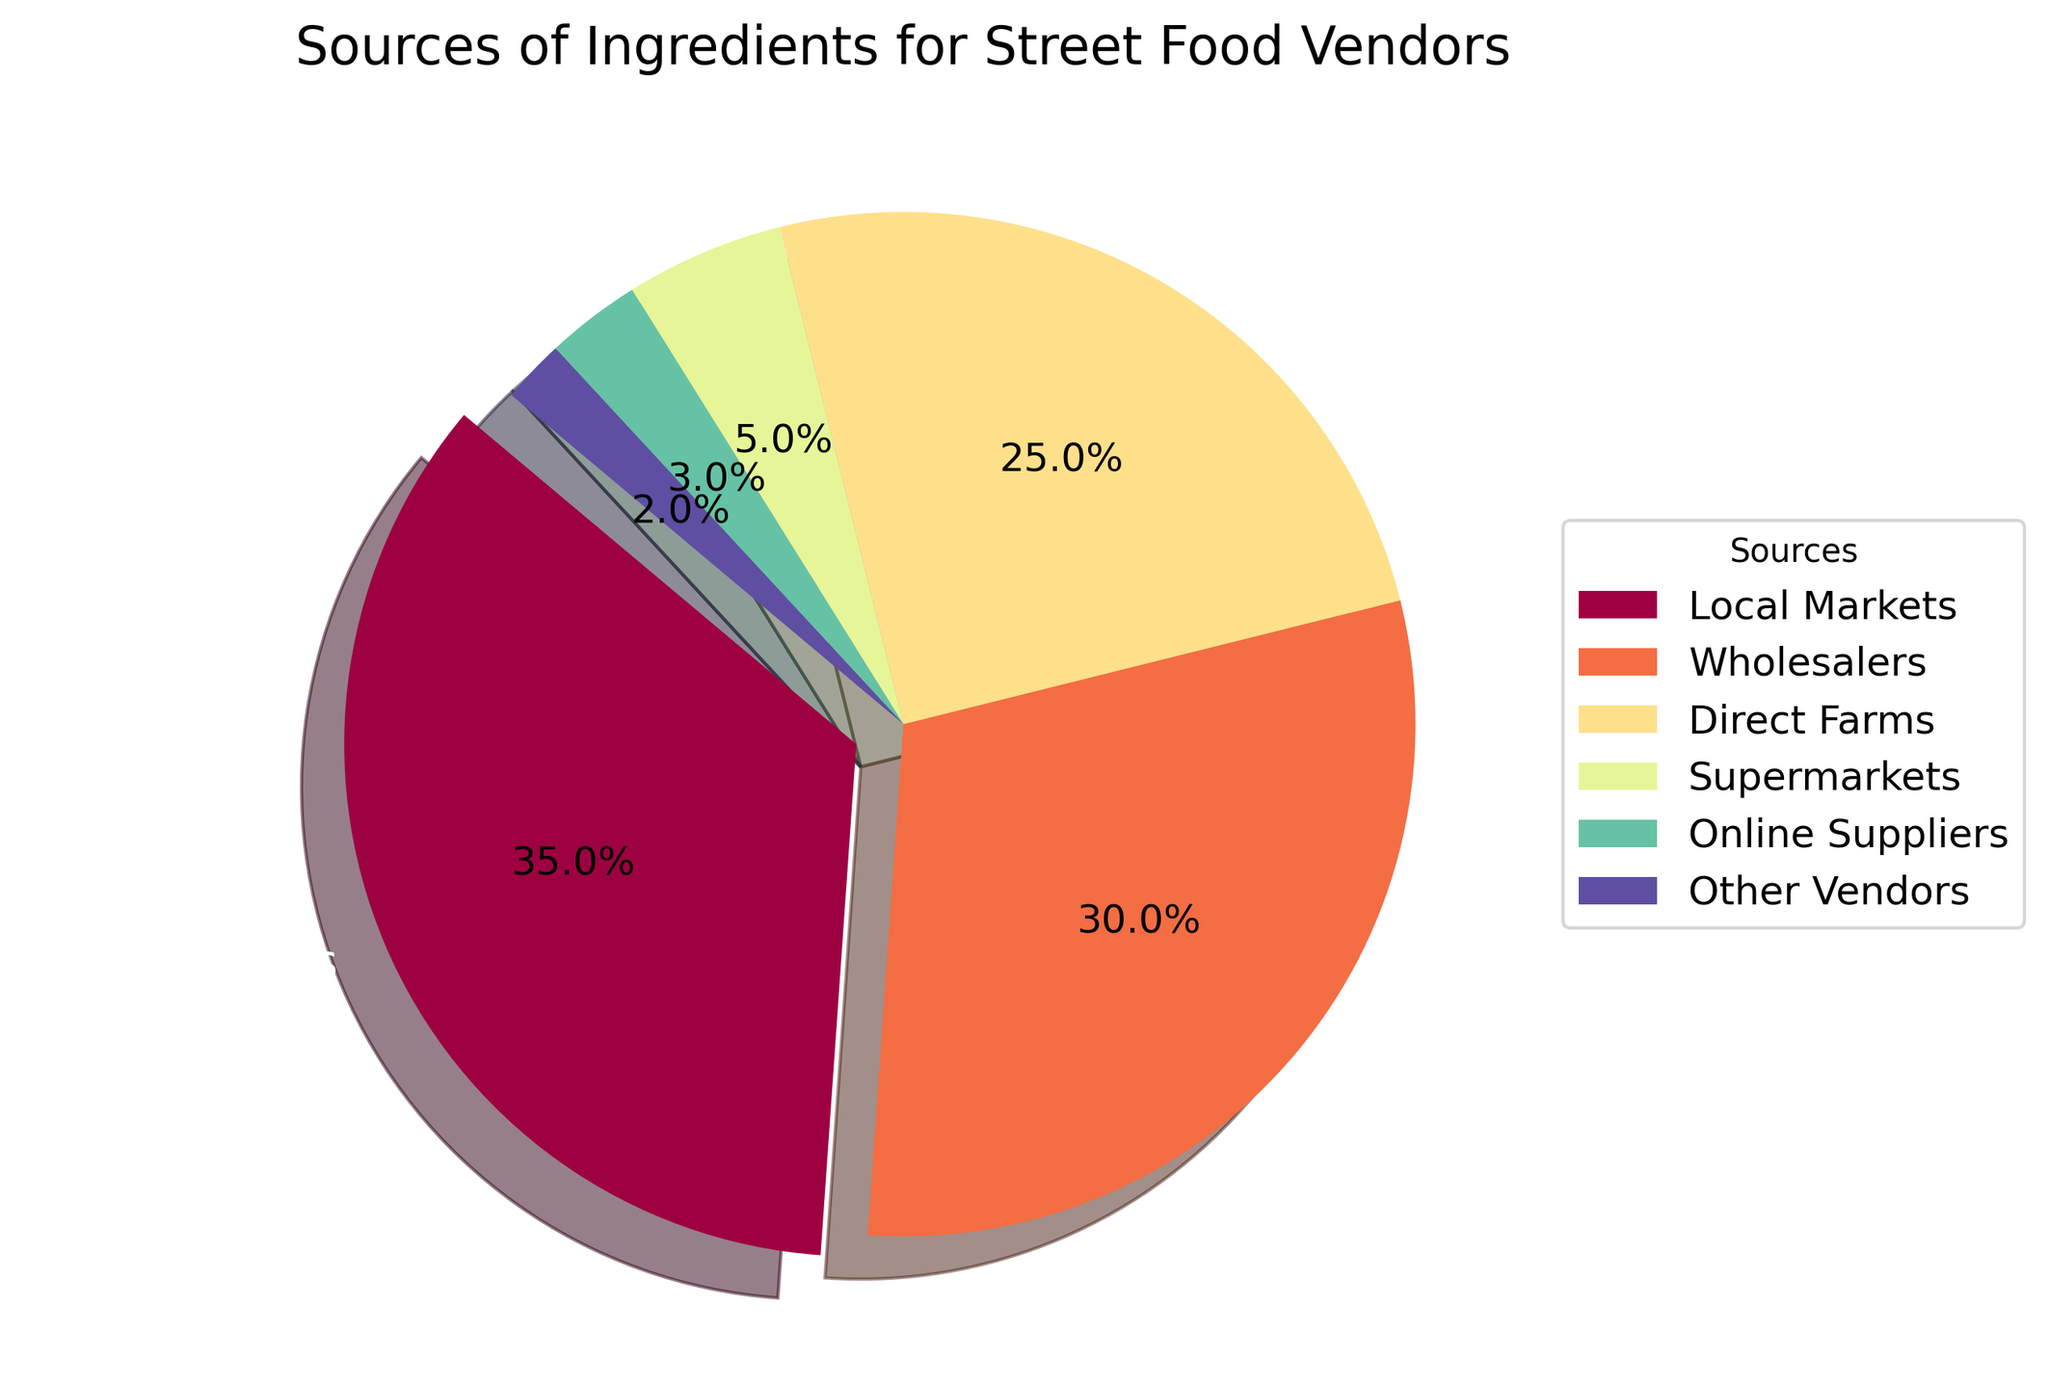What is the largest source of ingredients for street food vendors? The largest source is identified by the largest wedge in the pie chart, which is labeled "Local Markets" with 35%.
Answer: Local Markets Which source provides fewer ingredients, supermarkets or online suppliers? By comparing the pie chart labels and their percentages, supermarkets provide 5% whereas online suppliers provide 3%. Thus, online suppliers provide fewer ingredients.
Answer: Online Suppliers How much more do direct farms contribute compared to other vendors? Direct farms contribute 25% and other vendors contribute 2%. The difference is calculated as 25% - 2% = 23%.
Answer: 23% What is the combined percentage of ingredients from local markets and wholesalers? Local markets contribute 35% and wholesalers contribute 30%. Adding them together gives 35% + 30% = 65%.
Answer: 65% Which categories combined make up less than 10% of the sources? Checking the smallest wedges in the pie chart, supermarkets (5%), online suppliers (3%), and other vendors (2%) combined make 5% + 3% + 2% = 10%. Individually or grouped, they each fall below or equal to 10%.
Answer: Supermarkets, Online Suppliers, Other Vendors Comparing local markets and direct farms, which source has a larger contribution, and by how much? Local markets contribute 35% and direct farms contribute 25%. The difference is calculated as 35% - 25% = 10%.
Answer: Local Markets, 10% What is the proportion of sources contributing less than 5%? The sources contributing less than 5% are online suppliers (3%) and other vendors (2%). Adding them together gives 3% + 2% = 5%.
Answer: 5% Which source has the smallest contribution, and what is its percentage? The smallest wedge in the pie chart is labeled "Other Vendors," which has a contribution of 2%.
Answer: Other Vendors, 2% How does the contribution from wholesalers compare to the combined contribution from supermarkets and online suppliers? Wholesalers contribute 30%, while supermarkets and online suppliers combined contribute 5% + 3% = 8%. Thus, wholesalers contribute significantly more.
Answer: Wholesalers If we added new sources contributing equally 5%, what would be the new total percentage for all listed sources? The current total percentage is 100%. Adding new sources each with 5% means 100% + 5% = 105%.
Answer: 105% 